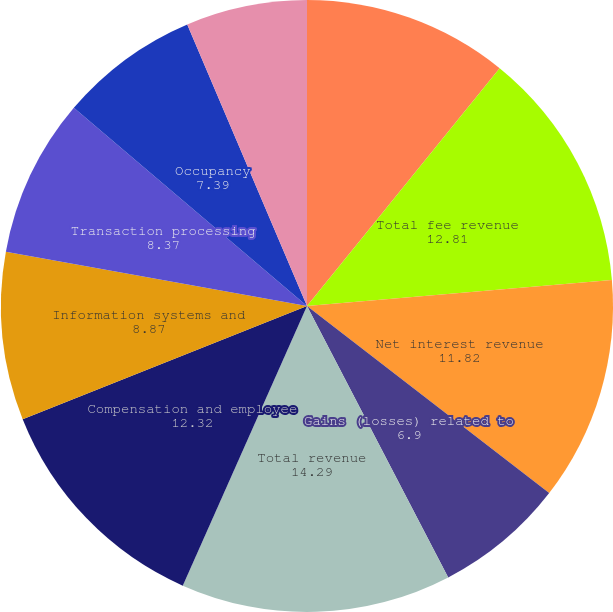Convert chart to OTSL. <chart><loc_0><loc_0><loc_500><loc_500><pie_chart><fcel>FOR THE YEAR ENDED DECEMBER 31<fcel>Total fee revenue<fcel>Net interest revenue<fcel>Gains (losses) related to<fcel>Total revenue<fcel>Compensation and employee<fcel>Information systems and<fcel>Transaction processing<fcel>Occupancy<fcel>Acquisition and restructuring<nl><fcel>10.84%<fcel>12.81%<fcel>11.82%<fcel>6.9%<fcel>14.29%<fcel>12.32%<fcel>8.87%<fcel>8.37%<fcel>7.39%<fcel>6.4%<nl></chart> 